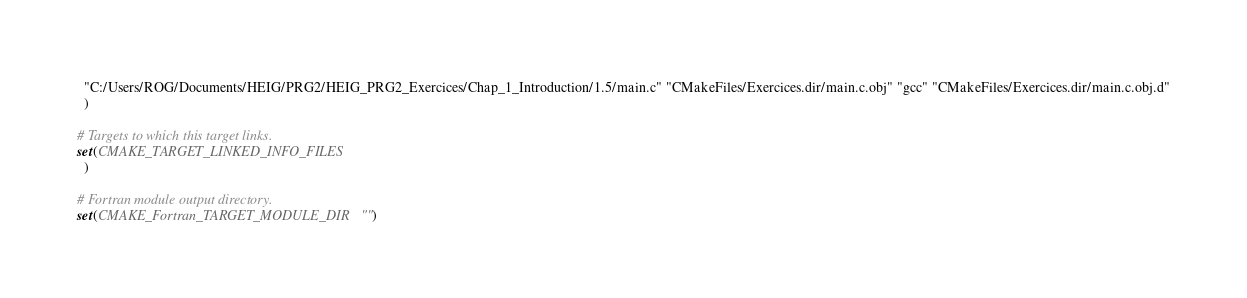<code> <loc_0><loc_0><loc_500><loc_500><_CMake_>  "C:/Users/ROG/Documents/HEIG/PRG2/HEIG_PRG2_Exercices/Chap_1_Introduction/1.5/main.c" "CMakeFiles/Exercices.dir/main.c.obj" "gcc" "CMakeFiles/Exercices.dir/main.c.obj.d"
  )

# Targets to which this target links.
set(CMAKE_TARGET_LINKED_INFO_FILES
  )

# Fortran module output directory.
set(CMAKE_Fortran_TARGET_MODULE_DIR "")
</code> 